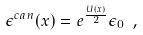<formula> <loc_0><loc_0><loc_500><loc_500>\epsilon ^ { c a n } ( x ) = e ^ { \frac { U ( x ) } { 2 } } \epsilon _ { 0 } \ ,</formula> 